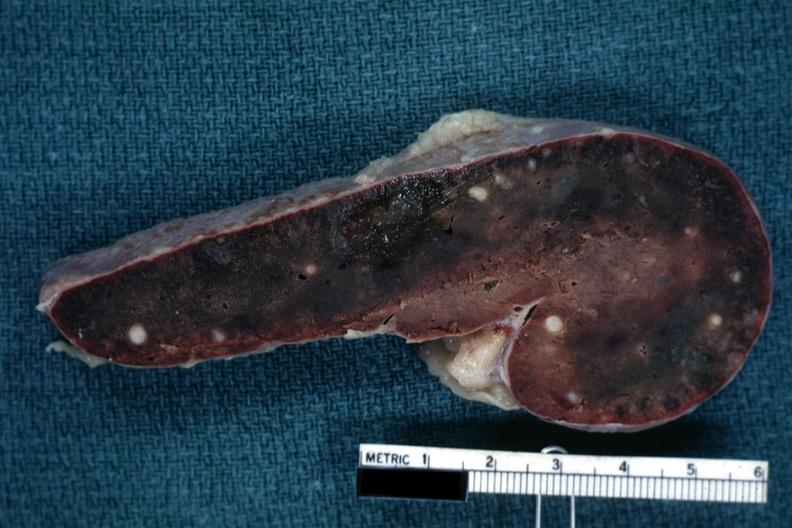s tuberculosis present?
Answer the question using a single word or phrase. Yes 